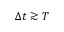Convert formula to latex. <formula><loc_0><loc_0><loc_500><loc_500>\Delta t \gtrsim T</formula> 